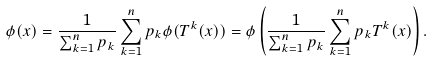Convert formula to latex. <formula><loc_0><loc_0><loc_500><loc_500>\phi ( x ) = \frac { 1 } { \sum _ { k = 1 } ^ { n } p _ { k } } \sum _ { k = 1 } ^ { n } p _ { k } \phi ( T ^ { k } ( x ) ) = \phi \left ( \frac { 1 } { \sum _ { k = 1 } ^ { n } p _ { k } } \sum _ { k = 1 } ^ { n } p _ { k } T ^ { k } ( x ) \right ) .</formula> 